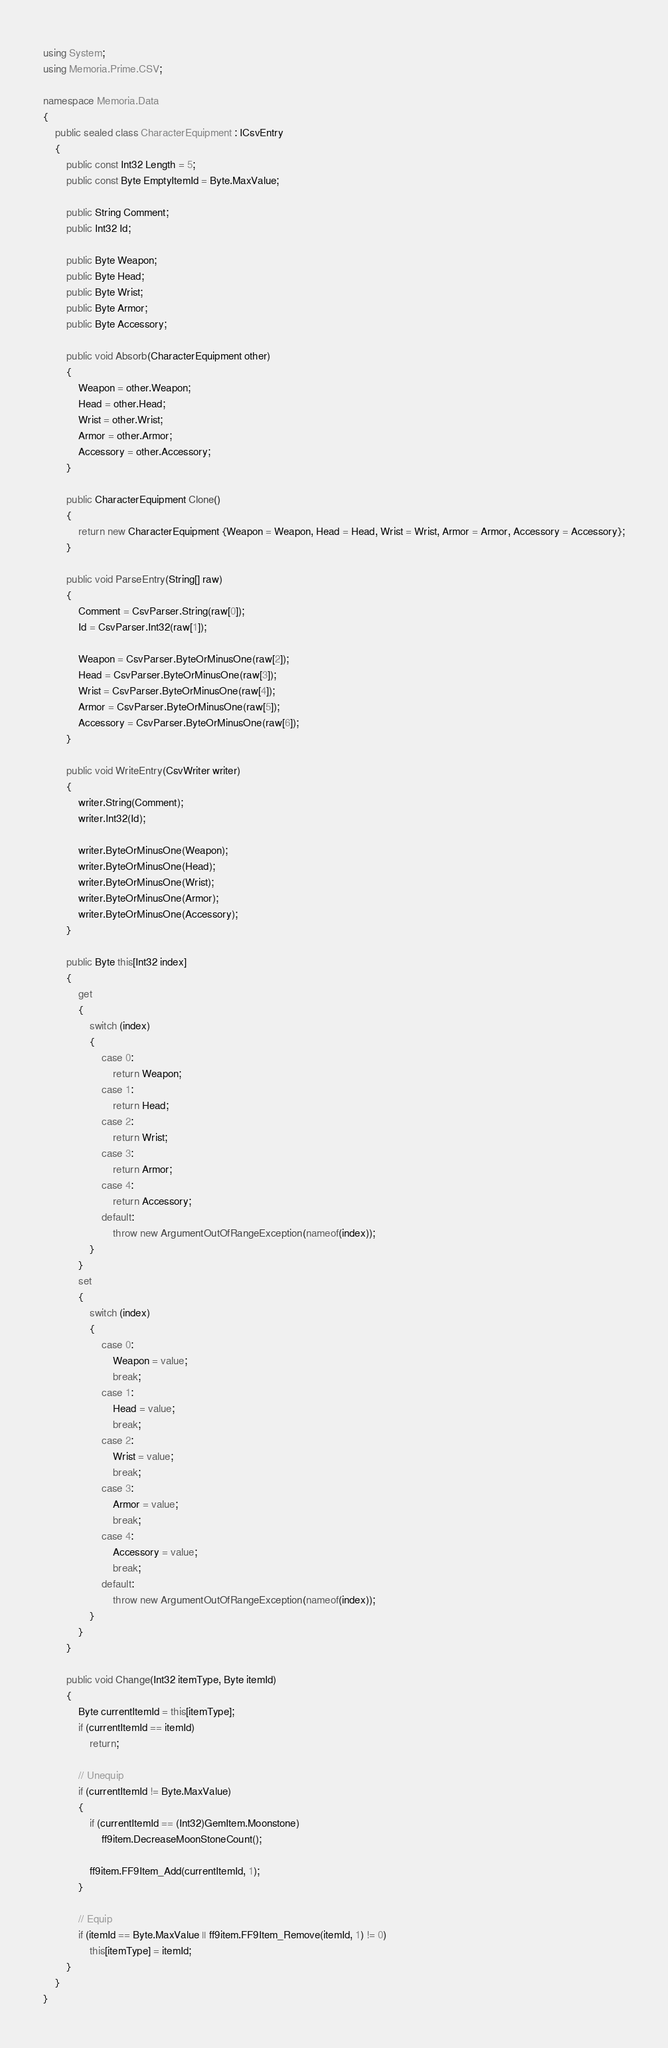Convert code to text. <code><loc_0><loc_0><loc_500><loc_500><_C#_>using System;
using Memoria.Prime.CSV;

namespace Memoria.Data
{
    public sealed class CharacterEquipment : ICsvEntry
    {
        public const Int32 Length = 5;
        public const Byte EmptyItemId = Byte.MaxValue;

        public String Comment;
        public Int32 Id;

        public Byte Weapon;
        public Byte Head;
        public Byte Wrist;
        public Byte Armor;
        public Byte Accessory;

        public void Absorb(CharacterEquipment other)
        {
            Weapon = other.Weapon;
            Head = other.Head;
            Wrist = other.Wrist;
            Armor = other.Armor;
            Accessory = other.Accessory;
        }

        public CharacterEquipment Clone()
        {
            return new CharacterEquipment {Weapon = Weapon, Head = Head, Wrist = Wrist, Armor = Armor, Accessory = Accessory};
        }

        public void ParseEntry(String[] raw)
        {
            Comment = CsvParser.String(raw[0]);
            Id = CsvParser.Int32(raw[1]);

            Weapon = CsvParser.ByteOrMinusOne(raw[2]);
            Head = CsvParser.ByteOrMinusOne(raw[3]);
            Wrist = CsvParser.ByteOrMinusOne(raw[4]);
            Armor = CsvParser.ByteOrMinusOne(raw[5]);
            Accessory = CsvParser.ByteOrMinusOne(raw[6]);
        }

        public void WriteEntry(CsvWriter writer)
        {
            writer.String(Comment);
            writer.Int32(Id);

            writer.ByteOrMinusOne(Weapon);
            writer.ByteOrMinusOne(Head);
            writer.ByteOrMinusOne(Wrist);
            writer.ByteOrMinusOne(Armor);
            writer.ByteOrMinusOne(Accessory);
        }

        public Byte this[Int32 index]
        {
            get
            {
                switch (index)
                {
                    case 0:
                        return Weapon;
                    case 1:
                        return Head;
                    case 2:
                        return Wrist;
                    case 3:
                        return Armor;
                    case 4:
                        return Accessory;
                    default:
                        throw new ArgumentOutOfRangeException(nameof(index));
                }
            }
            set
            {
                switch (index)
                {
                    case 0:
                        Weapon = value;
                        break;
                    case 1:
                        Head = value;
                        break;
                    case 2:
                        Wrist = value;
                        break;
                    case 3:
                        Armor = value;
                        break;
                    case 4:
                        Accessory = value;
                        break;
                    default:
                        throw new ArgumentOutOfRangeException(nameof(index));
                }
            }
        }

        public void Change(Int32 itemType, Byte itemId)
        {
            Byte currentItemId = this[itemType];
            if (currentItemId == itemId)
                return;

            // Unequip
            if (currentItemId != Byte.MaxValue)
            {
                if (currentItemId == (Int32)GemItem.Moonstone)
                    ff9item.DecreaseMoonStoneCount();

                ff9item.FF9Item_Add(currentItemId, 1);
            }

            // Equip
            if (itemId == Byte.MaxValue || ff9item.FF9Item_Remove(itemId, 1) != 0)
                this[itemType] = itemId;
        }
    }
}</code> 